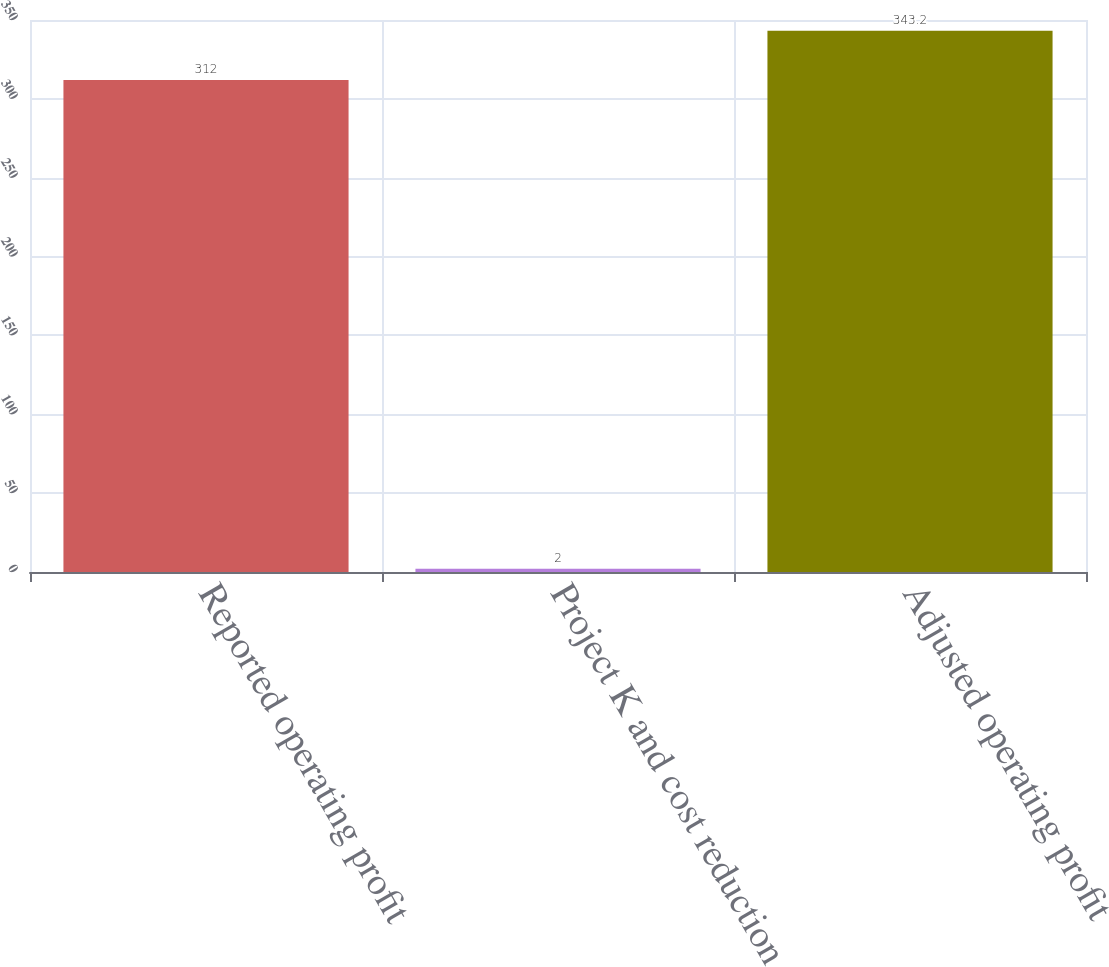Convert chart to OTSL. <chart><loc_0><loc_0><loc_500><loc_500><bar_chart><fcel>Reported operating profit<fcel>Project K and cost reduction<fcel>Adjusted operating profit<nl><fcel>312<fcel>2<fcel>343.2<nl></chart> 